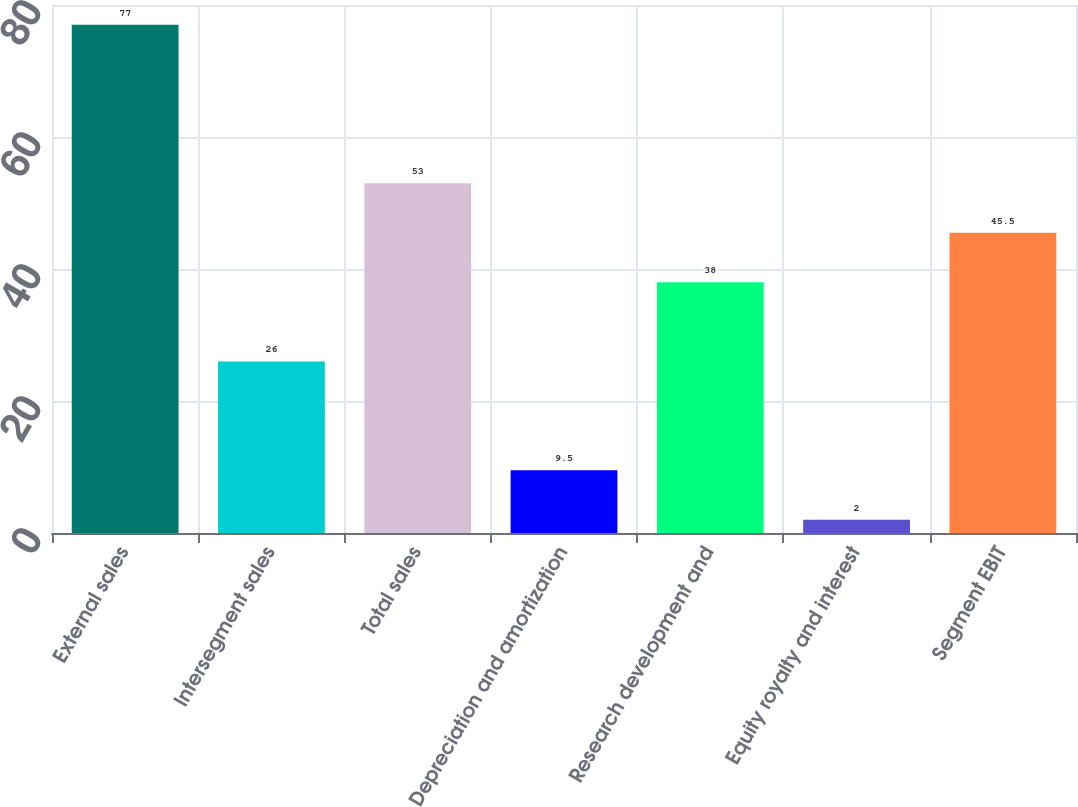Convert chart to OTSL. <chart><loc_0><loc_0><loc_500><loc_500><bar_chart><fcel>External sales<fcel>Intersegment sales<fcel>Total sales<fcel>Depreciation and amortization<fcel>Research development and<fcel>Equity royalty and interest<fcel>Segment EBIT<nl><fcel>77<fcel>26<fcel>53<fcel>9.5<fcel>38<fcel>2<fcel>45.5<nl></chart> 